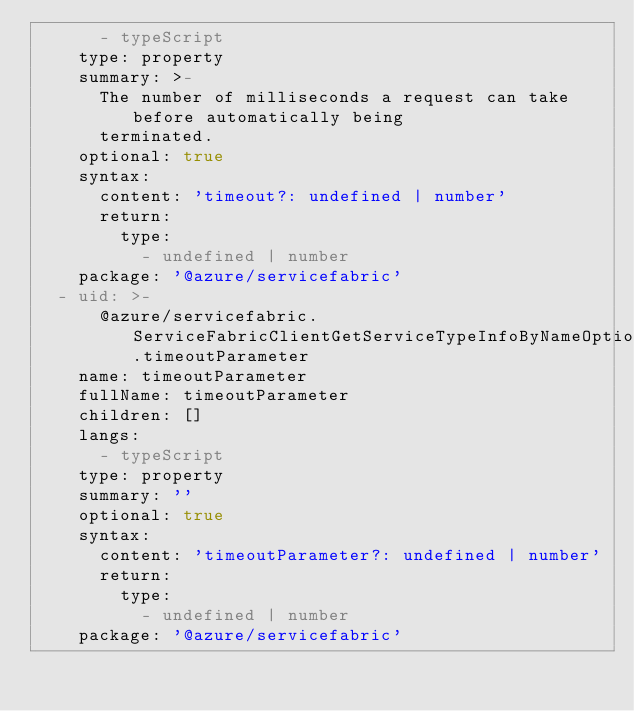<code> <loc_0><loc_0><loc_500><loc_500><_YAML_>      - typeScript
    type: property
    summary: >-
      The number of milliseconds a request can take before automatically being
      terminated.
    optional: true
    syntax:
      content: 'timeout?: undefined | number'
      return:
        type:
          - undefined | number
    package: '@azure/servicefabric'
  - uid: >-
      @azure/servicefabric.ServiceFabricClientGetServiceTypeInfoByNameOptionalParams.timeoutParameter
    name: timeoutParameter
    fullName: timeoutParameter
    children: []
    langs:
      - typeScript
    type: property
    summary: ''
    optional: true
    syntax:
      content: 'timeoutParameter?: undefined | number'
      return:
        type:
          - undefined | number
    package: '@azure/servicefabric'
</code> 